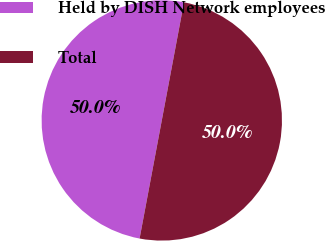Convert chart. <chart><loc_0><loc_0><loc_500><loc_500><pie_chart><fcel>Held by DISH Network employees<fcel>Total<nl><fcel>50.0%<fcel>50.0%<nl></chart> 